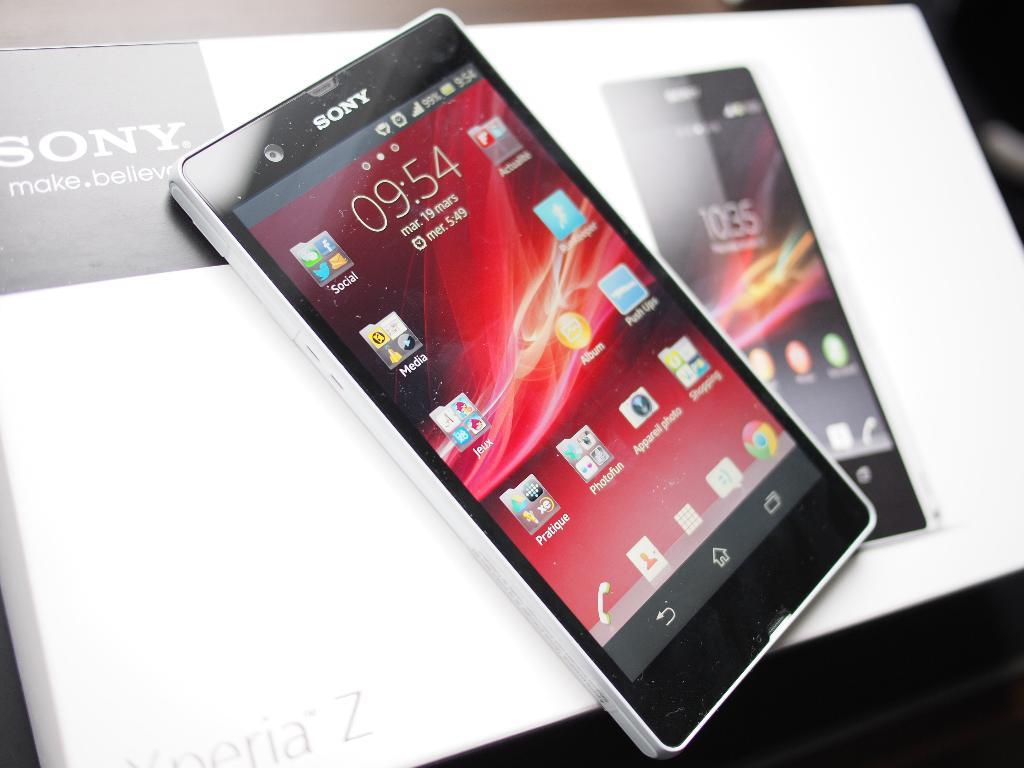<image>
Describe the image concisely. A Sony phone displays the home page with icons. 